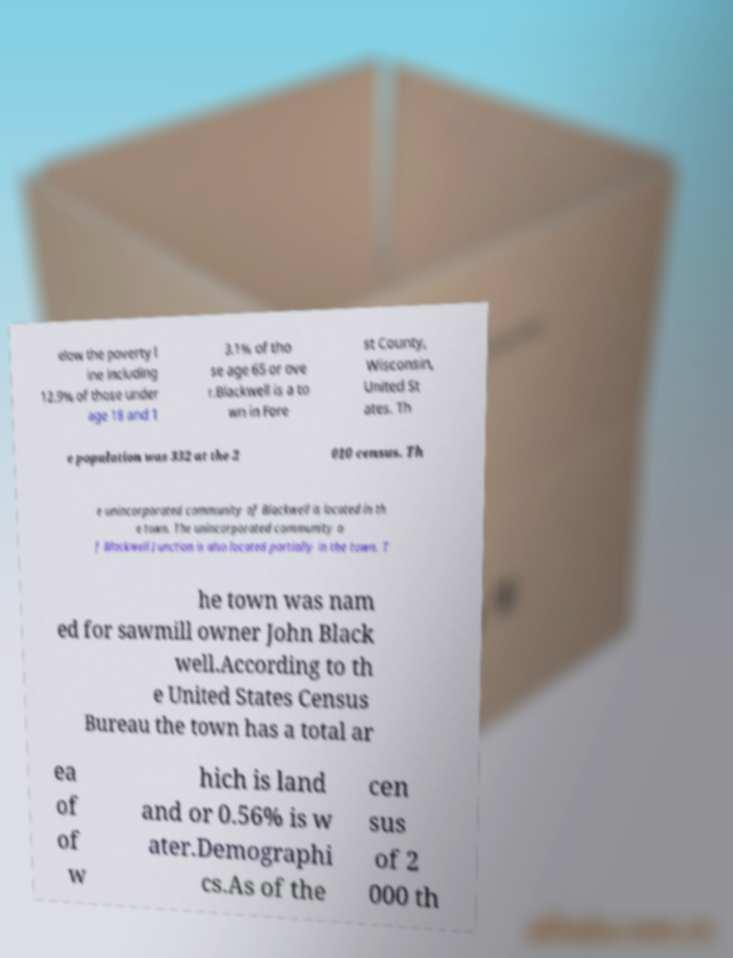What messages or text are displayed in this image? I need them in a readable, typed format. elow the poverty l ine including 12.9% of those under age 18 and 1 3.1% of tho se age 65 or ove r.Blackwell is a to wn in Fore st County, Wisconsin, United St ates. Th e population was 332 at the 2 010 census. Th e unincorporated community of Blackwell is located in th e town. The unincorporated community o f Blackwell Junction is also located partially in the town. T he town was nam ed for sawmill owner John Black well.According to th e United States Census Bureau the town has a total ar ea of of w hich is land and or 0.56% is w ater.Demographi cs.As of the cen sus of 2 000 th 